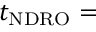Convert formula to latex. <formula><loc_0><loc_0><loc_500><loc_500>t _ { N D R O } =</formula> 